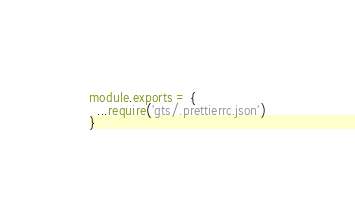<code> <loc_0><loc_0><loc_500><loc_500><_JavaScript_>module.exports = {
  ...require('gts/.prettierrc.json')
}
</code> 